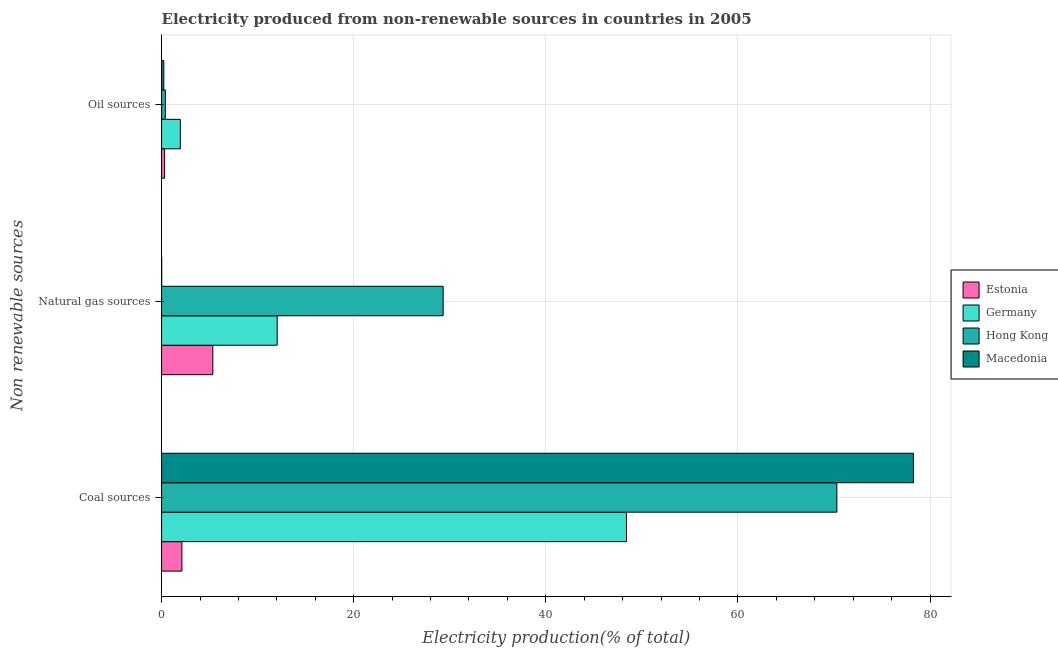How many groups of bars are there?
Your response must be concise. 3. What is the label of the 1st group of bars from the top?
Offer a terse response. Oil sources. What is the percentage of electricity produced by natural gas in Hong Kong?
Make the answer very short. 29.31. Across all countries, what is the maximum percentage of electricity produced by oil sources?
Offer a terse response. 1.95. Across all countries, what is the minimum percentage of electricity produced by coal?
Provide a succinct answer. 2.12. In which country was the percentage of electricity produced by natural gas maximum?
Your answer should be very brief. Hong Kong. In which country was the percentage of electricity produced by oil sources minimum?
Your answer should be compact. Macedonia. What is the total percentage of electricity produced by oil sources in the graph?
Provide a succinct answer. 2.89. What is the difference between the percentage of electricity produced by coal in Germany and that in Estonia?
Provide a short and direct response. 46.28. What is the difference between the percentage of electricity produced by oil sources in Macedonia and the percentage of electricity produced by natural gas in Germany?
Keep it short and to the point. -11.81. What is the average percentage of electricity produced by coal per country?
Offer a very short reply. 49.77. What is the difference between the percentage of electricity produced by natural gas and percentage of electricity produced by oil sources in Macedonia?
Your response must be concise. -0.22. What is the ratio of the percentage of electricity produced by oil sources in Hong Kong to that in Estonia?
Offer a terse response. 1.25. What is the difference between the highest and the second highest percentage of electricity produced by oil sources?
Offer a very short reply. 1.56. What is the difference between the highest and the lowest percentage of electricity produced by coal?
Your response must be concise. 76.16. Is the sum of the percentage of electricity produced by natural gas in Macedonia and Hong Kong greater than the maximum percentage of electricity produced by oil sources across all countries?
Provide a short and direct response. Yes. What does the 1st bar from the top in Coal sources represents?
Ensure brevity in your answer.  Macedonia. What does the 3rd bar from the bottom in Coal sources represents?
Your answer should be compact. Hong Kong. Is it the case that in every country, the sum of the percentage of electricity produced by coal and percentage of electricity produced by natural gas is greater than the percentage of electricity produced by oil sources?
Offer a terse response. Yes. What is the difference between two consecutive major ticks on the X-axis?
Provide a short and direct response. 20. Where does the legend appear in the graph?
Make the answer very short. Center right. How many legend labels are there?
Your answer should be very brief. 4. How are the legend labels stacked?
Keep it short and to the point. Vertical. What is the title of the graph?
Give a very brief answer. Electricity produced from non-renewable sources in countries in 2005. Does "Lebanon" appear as one of the legend labels in the graph?
Your answer should be very brief. No. What is the label or title of the X-axis?
Give a very brief answer. Electricity production(% of total). What is the label or title of the Y-axis?
Offer a terse response. Non renewable sources. What is the Electricity production(% of total) in Estonia in Coal sources?
Provide a short and direct response. 2.12. What is the Electricity production(% of total) in Germany in Coal sources?
Your response must be concise. 48.4. What is the Electricity production(% of total) of Hong Kong in Coal sources?
Provide a succinct answer. 70.3. What is the Electricity production(% of total) in Macedonia in Coal sources?
Provide a short and direct response. 78.27. What is the Electricity production(% of total) in Estonia in Natural gas sources?
Give a very brief answer. 5.33. What is the Electricity production(% of total) of Germany in Natural gas sources?
Your answer should be compact. 12.04. What is the Electricity production(% of total) of Hong Kong in Natural gas sources?
Keep it short and to the point. 29.31. What is the Electricity production(% of total) in Macedonia in Natural gas sources?
Your answer should be very brief. 0.01. What is the Electricity production(% of total) of Estonia in Oil sources?
Make the answer very short. 0.31. What is the Electricity production(% of total) of Germany in Oil sources?
Give a very brief answer. 1.95. What is the Electricity production(% of total) of Hong Kong in Oil sources?
Ensure brevity in your answer.  0.39. What is the Electricity production(% of total) of Macedonia in Oil sources?
Provide a short and direct response. 0.23. Across all Non renewable sources, what is the maximum Electricity production(% of total) of Estonia?
Keep it short and to the point. 5.33. Across all Non renewable sources, what is the maximum Electricity production(% of total) in Germany?
Ensure brevity in your answer.  48.4. Across all Non renewable sources, what is the maximum Electricity production(% of total) in Hong Kong?
Make the answer very short. 70.3. Across all Non renewable sources, what is the maximum Electricity production(% of total) of Macedonia?
Your response must be concise. 78.27. Across all Non renewable sources, what is the minimum Electricity production(% of total) in Estonia?
Keep it short and to the point. 0.31. Across all Non renewable sources, what is the minimum Electricity production(% of total) in Germany?
Offer a very short reply. 1.95. Across all Non renewable sources, what is the minimum Electricity production(% of total) in Hong Kong?
Your answer should be very brief. 0.39. Across all Non renewable sources, what is the minimum Electricity production(% of total) of Macedonia?
Offer a terse response. 0.01. What is the total Electricity production(% of total) in Estonia in the graph?
Your answer should be very brief. 7.76. What is the total Electricity production(% of total) of Germany in the graph?
Provide a succinct answer. 62.38. What is the total Electricity production(% of total) of Macedonia in the graph?
Offer a very short reply. 78.52. What is the difference between the Electricity production(% of total) in Estonia in Coal sources and that in Natural gas sources?
Your response must be concise. -3.21. What is the difference between the Electricity production(% of total) of Germany in Coal sources and that in Natural gas sources?
Your response must be concise. 36.36. What is the difference between the Electricity production(% of total) in Hong Kong in Coal sources and that in Natural gas sources?
Ensure brevity in your answer.  40.99. What is the difference between the Electricity production(% of total) in Macedonia in Coal sources and that in Natural gas sources?
Your answer should be very brief. 78.26. What is the difference between the Electricity production(% of total) of Estonia in Coal sources and that in Oil sources?
Your answer should be compact. 1.8. What is the difference between the Electricity production(% of total) in Germany in Coal sources and that in Oil sources?
Your response must be concise. 46.45. What is the difference between the Electricity production(% of total) in Hong Kong in Coal sources and that in Oil sources?
Offer a very short reply. 69.9. What is the difference between the Electricity production(% of total) in Macedonia in Coal sources and that in Oil sources?
Keep it short and to the point. 78.04. What is the difference between the Electricity production(% of total) in Estonia in Natural gas sources and that in Oil sources?
Give a very brief answer. 5.02. What is the difference between the Electricity production(% of total) in Germany in Natural gas sources and that in Oil sources?
Your response must be concise. 10.09. What is the difference between the Electricity production(% of total) of Hong Kong in Natural gas sources and that in Oil sources?
Keep it short and to the point. 28.92. What is the difference between the Electricity production(% of total) in Macedonia in Natural gas sources and that in Oil sources?
Provide a succinct answer. -0.22. What is the difference between the Electricity production(% of total) in Estonia in Coal sources and the Electricity production(% of total) in Germany in Natural gas sources?
Keep it short and to the point. -9.92. What is the difference between the Electricity production(% of total) in Estonia in Coal sources and the Electricity production(% of total) in Hong Kong in Natural gas sources?
Your answer should be very brief. -27.19. What is the difference between the Electricity production(% of total) of Estonia in Coal sources and the Electricity production(% of total) of Macedonia in Natural gas sources?
Keep it short and to the point. 2.1. What is the difference between the Electricity production(% of total) in Germany in Coal sources and the Electricity production(% of total) in Hong Kong in Natural gas sources?
Keep it short and to the point. 19.09. What is the difference between the Electricity production(% of total) of Germany in Coal sources and the Electricity production(% of total) of Macedonia in Natural gas sources?
Give a very brief answer. 48.38. What is the difference between the Electricity production(% of total) of Hong Kong in Coal sources and the Electricity production(% of total) of Macedonia in Natural gas sources?
Your response must be concise. 70.28. What is the difference between the Electricity production(% of total) in Estonia in Coal sources and the Electricity production(% of total) in Germany in Oil sources?
Offer a terse response. 0.17. What is the difference between the Electricity production(% of total) of Estonia in Coal sources and the Electricity production(% of total) of Hong Kong in Oil sources?
Your response must be concise. 1.72. What is the difference between the Electricity production(% of total) in Estonia in Coal sources and the Electricity production(% of total) in Macedonia in Oil sources?
Ensure brevity in your answer.  1.89. What is the difference between the Electricity production(% of total) in Germany in Coal sources and the Electricity production(% of total) in Hong Kong in Oil sources?
Your answer should be compact. 48. What is the difference between the Electricity production(% of total) of Germany in Coal sources and the Electricity production(% of total) of Macedonia in Oil sources?
Your answer should be very brief. 48.17. What is the difference between the Electricity production(% of total) in Hong Kong in Coal sources and the Electricity production(% of total) in Macedonia in Oil sources?
Provide a succinct answer. 70.07. What is the difference between the Electricity production(% of total) in Estonia in Natural gas sources and the Electricity production(% of total) in Germany in Oil sources?
Your answer should be very brief. 3.38. What is the difference between the Electricity production(% of total) in Estonia in Natural gas sources and the Electricity production(% of total) in Hong Kong in Oil sources?
Your response must be concise. 4.94. What is the difference between the Electricity production(% of total) of Estonia in Natural gas sources and the Electricity production(% of total) of Macedonia in Oil sources?
Offer a terse response. 5.1. What is the difference between the Electricity production(% of total) of Germany in Natural gas sources and the Electricity production(% of total) of Hong Kong in Oil sources?
Your response must be concise. 11.64. What is the difference between the Electricity production(% of total) of Germany in Natural gas sources and the Electricity production(% of total) of Macedonia in Oil sources?
Offer a very short reply. 11.81. What is the difference between the Electricity production(% of total) in Hong Kong in Natural gas sources and the Electricity production(% of total) in Macedonia in Oil sources?
Your answer should be compact. 29.08. What is the average Electricity production(% of total) in Estonia per Non renewable sources?
Keep it short and to the point. 2.59. What is the average Electricity production(% of total) of Germany per Non renewable sources?
Your answer should be very brief. 20.79. What is the average Electricity production(% of total) in Hong Kong per Non renewable sources?
Your answer should be compact. 33.33. What is the average Electricity production(% of total) of Macedonia per Non renewable sources?
Give a very brief answer. 26.17. What is the difference between the Electricity production(% of total) of Estonia and Electricity production(% of total) of Germany in Coal sources?
Keep it short and to the point. -46.28. What is the difference between the Electricity production(% of total) of Estonia and Electricity production(% of total) of Hong Kong in Coal sources?
Keep it short and to the point. -68.18. What is the difference between the Electricity production(% of total) in Estonia and Electricity production(% of total) in Macedonia in Coal sources?
Keep it short and to the point. -76.16. What is the difference between the Electricity production(% of total) of Germany and Electricity production(% of total) of Hong Kong in Coal sources?
Offer a very short reply. -21.9. What is the difference between the Electricity production(% of total) of Germany and Electricity production(% of total) of Macedonia in Coal sources?
Offer a terse response. -29.88. What is the difference between the Electricity production(% of total) in Hong Kong and Electricity production(% of total) in Macedonia in Coal sources?
Your response must be concise. -7.97. What is the difference between the Electricity production(% of total) in Estonia and Electricity production(% of total) in Germany in Natural gas sources?
Your answer should be compact. -6.7. What is the difference between the Electricity production(% of total) of Estonia and Electricity production(% of total) of Hong Kong in Natural gas sources?
Provide a short and direct response. -23.98. What is the difference between the Electricity production(% of total) in Estonia and Electricity production(% of total) in Macedonia in Natural gas sources?
Provide a succinct answer. 5.32. What is the difference between the Electricity production(% of total) of Germany and Electricity production(% of total) of Hong Kong in Natural gas sources?
Offer a very short reply. -17.27. What is the difference between the Electricity production(% of total) of Germany and Electricity production(% of total) of Macedonia in Natural gas sources?
Your answer should be compact. 12.02. What is the difference between the Electricity production(% of total) of Hong Kong and Electricity production(% of total) of Macedonia in Natural gas sources?
Keep it short and to the point. 29.3. What is the difference between the Electricity production(% of total) in Estonia and Electricity production(% of total) in Germany in Oil sources?
Make the answer very short. -1.64. What is the difference between the Electricity production(% of total) in Estonia and Electricity production(% of total) in Hong Kong in Oil sources?
Keep it short and to the point. -0.08. What is the difference between the Electricity production(% of total) of Estonia and Electricity production(% of total) of Macedonia in Oil sources?
Your response must be concise. 0.08. What is the difference between the Electricity production(% of total) of Germany and Electricity production(% of total) of Hong Kong in Oil sources?
Your answer should be compact. 1.56. What is the difference between the Electricity production(% of total) in Germany and Electricity production(% of total) in Macedonia in Oil sources?
Provide a succinct answer. 1.72. What is the difference between the Electricity production(% of total) in Hong Kong and Electricity production(% of total) in Macedonia in Oil sources?
Ensure brevity in your answer.  0.16. What is the ratio of the Electricity production(% of total) of Estonia in Coal sources to that in Natural gas sources?
Ensure brevity in your answer.  0.4. What is the ratio of the Electricity production(% of total) of Germany in Coal sources to that in Natural gas sources?
Your answer should be compact. 4.02. What is the ratio of the Electricity production(% of total) in Hong Kong in Coal sources to that in Natural gas sources?
Your response must be concise. 2.4. What is the ratio of the Electricity production(% of total) in Macedonia in Coal sources to that in Natural gas sources?
Provide a succinct answer. 5436. What is the ratio of the Electricity production(% of total) in Estonia in Coal sources to that in Oil sources?
Provide a short and direct response. 6.75. What is the ratio of the Electricity production(% of total) of Germany in Coal sources to that in Oil sources?
Provide a short and direct response. 24.82. What is the ratio of the Electricity production(% of total) in Hong Kong in Coal sources to that in Oil sources?
Provide a succinct answer. 179.01. What is the ratio of the Electricity production(% of total) of Macedonia in Coal sources to that in Oil sources?
Ensure brevity in your answer.  339.75. What is the ratio of the Electricity production(% of total) in Estonia in Natural gas sources to that in Oil sources?
Provide a succinct answer. 17. What is the ratio of the Electricity production(% of total) of Germany in Natural gas sources to that in Oil sources?
Provide a succinct answer. 6.17. What is the ratio of the Electricity production(% of total) in Hong Kong in Natural gas sources to that in Oil sources?
Your answer should be compact. 74.64. What is the ratio of the Electricity production(% of total) of Macedonia in Natural gas sources to that in Oil sources?
Keep it short and to the point. 0.06. What is the difference between the highest and the second highest Electricity production(% of total) in Estonia?
Offer a terse response. 3.21. What is the difference between the highest and the second highest Electricity production(% of total) of Germany?
Make the answer very short. 36.36. What is the difference between the highest and the second highest Electricity production(% of total) in Hong Kong?
Provide a succinct answer. 40.99. What is the difference between the highest and the second highest Electricity production(% of total) in Macedonia?
Keep it short and to the point. 78.04. What is the difference between the highest and the lowest Electricity production(% of total) of Estonia?
Ensure brevity in your answer.  5.02. What is the difference between the highest and the lowest Electricity production(% of total) of Germany?
Make the answer very short. 46.45. What is the difference between the highest and the lowest Electricity production(% of total) in Hong Kong?
Give a very brief answer. 69.9. What is the difference between the highest and the lowest Electricity production(% of total) in Macedonia?
Your answer should be compact. 78.26. 